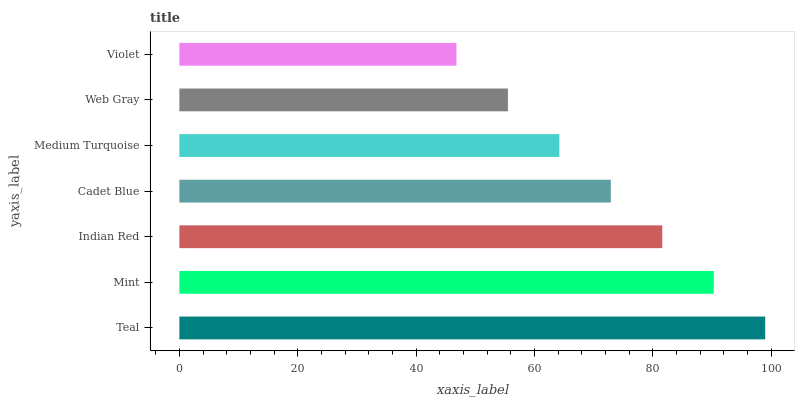Is Violet the minimum?
Answer yes or no. Yes. Is Teal the maximum?
Answer yes or no. Yes. Is Mint the minimum?
Answer yes or no. No. Is Mint the maximum?
Answer yes or no. No. Is Teal greater than Mint?
Answer yes or no. Yes. Is Mint less than Teal?
Answer yes or no. Yes. Is Mint greater than Teal?
Answer yes or no. No. Is Teal less than Mint?
Answer yes or no. No. Is Cadet Blue the high median?
Answer yes or no. Yes. Is Cadet Blue the low median?
Answer yes or no. Yes. Is Teal the high median?
Answer yes or no. No. Is Violet the low median?
Answer yes or no. No. 